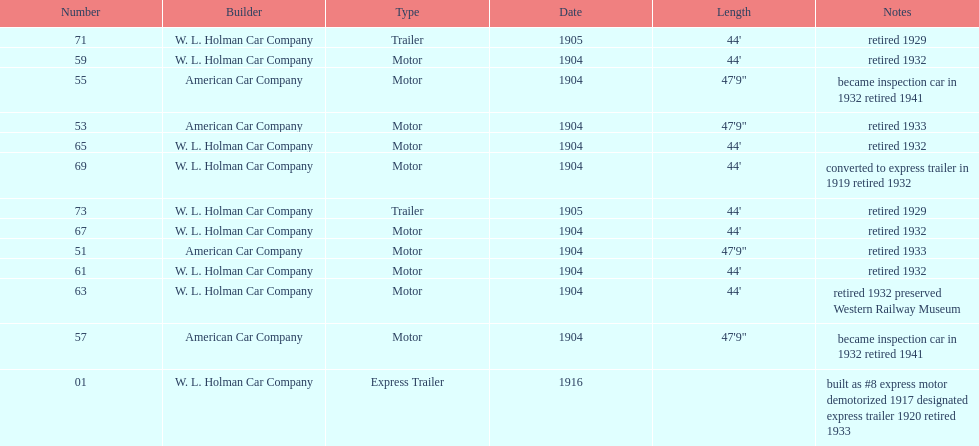How long did it take number 71 to retire? 24. 